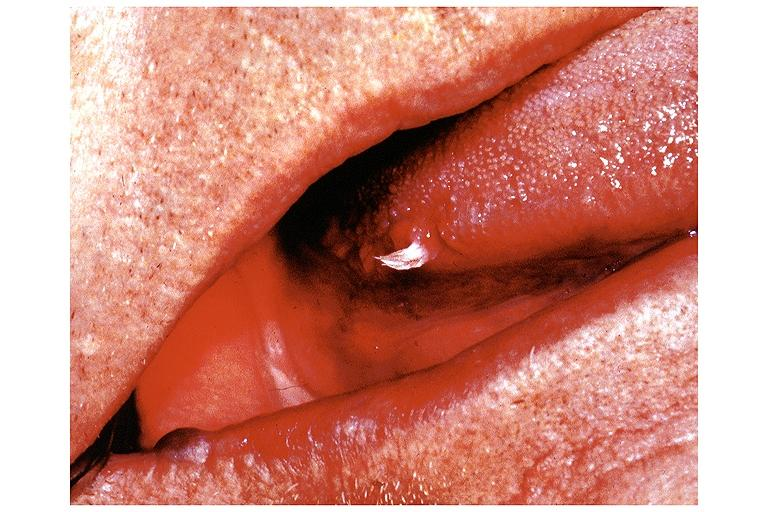what does this image show?
Answer the question using a single word or phrase. Papilloma 